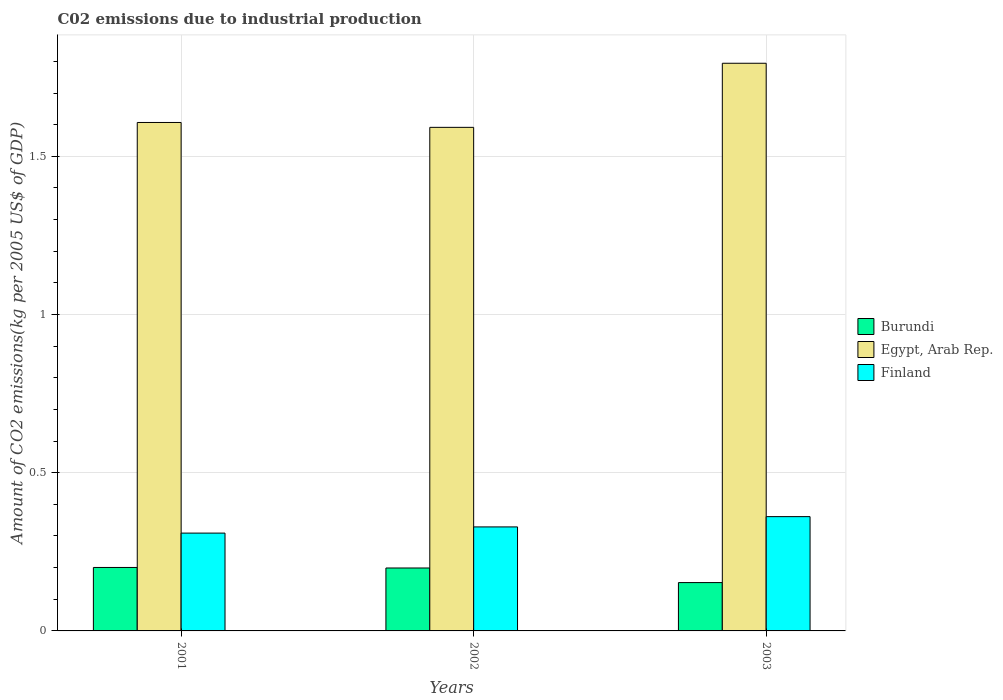How many different coloured bars are there?
Provide a succinct answer. 3. How many bars are there on the 3rd tick from the left?
Your answer should be compact. 3. What is the amount of CO2 emitted due to industrial production in Finland in 2003?
Your answer should be very brief. 0.36. Across all years, what is the maximum amount of CO2 emitted due to industrial production in Finland?
Provide a succinct answer. 0.36. Across all years, what is the minimum amount of CO2 emitted due to industrial production in Egypt, Arab Rep.?
Offer a terse response. 1.59. In which year was the amount of CO2 emitted due to industrial production in Egypt, Arab Rep. minimum?
Keep it short and to the point. 2002. What is the total amount of CO2 emitted due to industrial production in Finland in the graph?
Offer a terse response. 1. What is the difference between the amount of CO2 emitted due to industrial production in Egypt, Arab Rep. in 2001 and that in 2002?
Provide a short and direct response. 0.02. What is the difference between the amount of CO2 emitted due to industrial production in Finland in 2003 and the amount of CO2 emitted due to industrial production in Burundi in 2001?
Keep it short and to the point. 0.16. What is the average amount of CO2 emitted due to industrial production in Burundi per year?
Your answer should be compact. 0.18. In the year 2003, what is the difference between the amount of CO2 emitted due to industrial production in Finland and amount of CO2 emitted due to industrial production in Egypt, Arab Rep.?
Offer a terse response. -1.43. In how many years, is the amount of CO2 emitted due to industrial production in Burundi greater than 0.30000000000000004 kg?
Your response must be concise. 0. What is the ratio of the amount of CO2 emitted due to industrial production in Finland in 2001 to that in 2003?
Ensure brevity in your answer.  0.86. Is the difference between the amount of CO2 emitted due to industrial production in Finland in 2001 and 2002 greater than the difference between the amount of CO2 emitted due to industrial production in Egypt, Arab Rep. in 2001 and 2002?
Keep it short and to the point. No. What is the difference between the highest and the second highest amount of CO2 emitted due to industrial production in Burundi?
Offer a very short reply. 0. What is the difference between the highest and the lowest amount of CO2 emitted due to industrial production in Burundi?
Ensure brevity in your answer.  0.05. In how many years, is the amount of CO2 emitted due to industrial production in Egypt, Arab Rep. greater than the average amount of CO2 emitted due to industrial production in Egypt, Arab Rep. taken over all years?
Make the answer very short. 1. What does the 1st bar from the left in 2003 represents?
Your answer should be compact. Burundi. What does the 1st bar from the right in 2003 represents?
Your answer should be compact. Finland. Is it the case that in every year, the sum of the amount of CO2 emitted due to industrial production in Burundi and amount of CO2 emitted due to industrial production in Finland is greater than the amount of CO2 emitted due to industrial production in Egypt, Arab Rep.?
Give a very brief answer. No. What is the title of the graph?
Your answer should be very brief. C02 emissions due to industrial production. What is the label or title of the X-axis?
Provide a succinct answer. Years. What is the label or title of the Y-axis?
Provide a short and direct response. Amount of CO2 emissions(kg per 2005 US$ of GDP). What is the Amount of CO2 emissions(kg per 2005 US$ of GDP) of Burundi in 2001?
Your answer should be very brief. 0.2. What is the Amount of CO2 emissions(kg per 2005 US$ of GDP) of Egypt, Arab Rep. in 2001?
Offer a terse response. 1.61. What is the Amount of CO2 emissions(kg per 2005 US$ of GDP) in Finland in 2001?
Your answer should be compact. 0.31. What is the Amount of CO2 emissions(kg per 2005 US$ of GDP) in Burundi in 2002?
Your answer should be compact. 0.2. What is the Amount of CO2 emissions(kg per 2005 US$ of GDP) in Egypt, Arab Rep. in 2002?
Your response must be concise. 1.59. What is the Amount of CO2 emissions(kg per 2005 US$ of GDP) in Finland in 2002?
Your answer should be compact. 0.33. What is the Amount of CO2 emissions(kg per 2005 US$ of GDP) in Burundi in 2003?
Your answer should be very brief. 0.15. What is the Amount of CO2 emissions(kg per 2005 US$ of GDP) of Egypt, Arab Rep. in 2003?
Offer a terse response. 1.79. What is the Amount of CO2 emissions(kg per 2005 US$ of GDP) in Finland in 2003?
Your response must be concise. 0.36. Across all years, what is the maximum Amount of CO2 emissions(kg per 2005 US$ of GDP) of Burundi?
Ensure brevity in your answer.  0.2. Across all years, what is the maximum Amount of CO2 emissions(kg per 2005 US$ of GDP) in Egypt, Arab Rep.?
Provide a short and direct response. 1.79. Across all years, what is the maximum Amount of CO2 emissions(kg per 2005 US$ of GDP) in Finland?
Provide a succinct answer. 0.36. Across all years, what is the minimum Amount of CO2 emissions(kg per 2005 US$ of GDP) of Burundi?
Your answer should be compact. 0.15. Across all years, what is the minimum Amount of CO2 emissions(kg per 2005 US$ of GDP) in Egypt, Arab Rep.?
Your response must be concise. 1.59. Across all years, what is the minimum Amount of CO2 emissions(kg per 2005 US$ of GDP) in Finland?
Your response must be concise. 0.31. What is the total Amount of CO2 emissions(kg per 2005 US$ of GDP) of Burundi in the graph?
Ensure brevity in your answer.  0.55. What is the total Amount of CO2 emissions(kg per 2005 US$ of GDP) in Egypt, Arab Rep. in the graph?
Provide a succinct answer. 4.99. What is the difference between the Amount of CO2 emissions(kg per 2005 US$ of GDP) of Burundi in 2001 and that in 2002?
Keep it short and to the point. 0. What is the difference between the Amount of CO2 emissions(kg per 2005 US$ of GDP) of Egypt, Arab Rep. in 2001 and that in 2002?
Ensure brevity in your answer.  0.02. What is the difference between the Amount of CO2 emissions(kg per 2005 US$ of GDP) of Finland in 2001 and that in 2002?
Make the answer very short. -0.02. What is the difference between the Amount of CO2 emissions(kg per 2005 US$ of GDP) in Burundi in 2001 and that in 2003?
Your answer should be very brief. 0.05. What is the difference between the Amount of CO2 emissions(kg per 2005 US$ of GDP) of Egypt, Arab Rep. in 2001 and that in 2003?
Provide a short and direct response. -0.19. What is the difference between the Amount of CO2 emissions(kg per 2005 US$ of GDP) in Finland in 2001 and that in 2003?
Give a very brief answer. -0.05. What is the difference between the Amount of CO2 emissions(kg per 2005 US$ of GDP) of Burundi in 2002 and that in 2003?
Keep it short and to the point. 0.05. What is the difference between the Amount of CO2 emissions(kg per 2005 US$ of GDP) of Egypt, Arab Rep. in 2002 and that in 2003?
Your answer should be compact. -0.2. What is the difference between the Amount of CO2 emissions(kg per 2005 US$ of GDP) of Finland in 2002 and that in 2003?
Offer a very short reply. -0.03. What is the difference between the Amount of CO2 emissions(kg per 2005 US$ of GDP) in Burundi in 2001 and the Amount of CO2 emissions(kg per 2005 US$ of GDP) in Egypt, Arab Rep. in 2002?
Make the answer very short. -1.39. What is the difference between the Amount of CO2 emissions(kg per 2005 US$ of GDP) of Burundi in 2001 and the Amount of CO2 emissions(kg per 2005 US$ of GDP) of Finland in 2002?
Offer a terse response. -0.13. What is the difference between the Amount of CO2 emissions(kg per 2005 US$ of GDP) in Egypt, Arab Rep. in 2001 and the Amount of CO2 emissions(kg per 2005 US$ of GDP) in Finland in 2002?
Make the answer very short. 1.28. What is the difference between the Amount of CO2 emissions(kg per 2005 US$ of GDP) of Burundi in 2001 and the Amount of CO2 emissions(kg per 2005 US$ of GDP) of Egypt, Arab Rep. in 2003?
Keep it short and to the point. -1.59. What is the difference between the Amount of CO2 emissions(kg per 2005 US$ of GDP) of Burundi in 2001 and the Amount of CO2 emissions(kg per 2005 US$ of GDP) of Finland in 2003?
Keep it short and to the point. -0.16. What is the difference between the Amount of CO2 emissions(kg per 2005 US$ of GDP) of Egypt, Arab Rep. in 2001 and the Amount of CO2 emissions(kg per 2005 US$ of GDP) of Finland in 2003?
Ensure brevity in your answer.  1.25. What is the difference between the Amount of CO2 emissions(kg per 2005 US$ of GDP) of Burundi in 2002 and the Amount of CO2 emissions(kg per 2005 US$ of GDP) of Egypt, Arab Rep. in 2003?
Ensure brevity in your answer.  -1.6. What is the difference between the Amount of CO2 emissions(kg per 2005 US$ of GDP) of Burundi in 2002 and the Amount of CO2 emissions(kg per 2005 US$ of GDP) of Finland in 2003?
Provide a short and direct response. -0.16. What is the difference between the Amount of CO2 emissions(kg per 2005 US$ of GDP) of Egypt, Arab Rep. in 2002 and the Amount of CO2 emissions(kg per 2005 US$ of GDP) of Finland in 2003?
Offer a terse response. 1.23. What is the average Amount of CO2 emissions(kg per 2005 US$ of GDP) in Burundi per year?
Your answer should be compact. 0.18. What is the average Amount of CO2 emissions(kg per 2005 US$ of GDP) of Egypt, Arab Rep. per year?
Ensure brevity in your answer.  1.66. What is the average Amount of CO2 emissions(kg per 2005 US$ of GDP) of Finland per year?
Keep it short and to the point. 0.33. In the year 2001, what is the difference between the Amount of CO2 emissions(kg per 2005 US$ of GDP) in Burundi and Amount of CO2 emissions(kg per 2005 US$ of GDP) in Egypt, Arab Rep.?
Offer a terse response. -1.41. In the year 2001, what is the difference between the Amount of CO2 emissions(kg per 2005 US$ of GDP) in Burundi and Amount of CO2 emissions(kg per 2005 US$ of GDP) in Finland?
Your response must be concise. -0.11. In the year 2001, what is the difference between the Amount of CO2 emissions(kg per 2005 US$ of GDP) in Egypt, Arab Rep. and Amount of CO2 emissions(kg per 2005 US$ of GDP) in Finland?
Give a very brief answer. 1.3. In the year 2002, what is the difference between the Amount of CO2 emissions(kg per 2005 US$ of GDP) in Burundi and Amount of CO2 emissions(kg per 2005 US$ of GDP) in Egypt, Arab Rep.?
Your answer should be compact. -1.39. In the year 2002, what is the difference between the Amount of CO2 emissions(kg per 2005 US$ of GDP) of Burundi and Amount of CO2 emissions(kg per 2005 US$ of GDP) of Finland?
Ensure brevity in your answer.  -0.13. In the year 2002, what is the difference between the Amount of CO2 emissions(kg per 2005 US$ of GDP) of Egypt, Arab Rep. and Amount of CO2 emissions(kg per 2005 US$ of GDP) of Finland?
Provide a short and direct response. 1.26. In the year 2003, what is the difference between the Amount of CO2 emissions(kg per 2005 US$ of GDP) of Burundi and Amount of CO2 emissions(kg per 2005 US$ of GDP) of Egypt, Arab Rep.?
Your answer should be very brief. -1.64. In the year 2003, what is the difference between the Amount of CO2 emissions(kg per 2005 US$ of GDP) of Burundi and Amount of CO2 emissions(kg per 2005 US$ of GDP) of Finland?
Offer a very short reply. -0.21. In the year 2003, what is the difference between the Amount of CO2 emissions(kg per 2005 US$ of GDP) of Egypt, Arab Rep. and Amount of CO2 emissions(kg per 2005 US$ of GDP) of Finland?
Your response must be concise. 1.43. What is the ratio of the Amount of CO2 emissions(kg per 2005 US$ of GDP) of Burundi in 2001 to that in 2002?
Your answer should be compact. 1.01. What is the ratio of the Amount of CO2 emissions(kg per 2005 US$ of GDP) of Egypt, Arab Rep. in 2001 to that in 2002?
Your answer should be compact. 1.01. What is the ratio of the Amount of CO2 emissions(kg per 2005 US$ of GDP) of Finland in 2001 to that in 2002?
Give a very brief answer. 0.94. What is the ratio of the Amount of CO2 emissions(kg per 2005 US$ of GDP) of Burundi in 2001 to that in 2003?
Ensure brevity in your answer.  1.31. What is the ratio of the Amount of CO2 emissions(kg per 2005 US$ of GDP) in Egypt, Arab Rep. in 2001 to that in 2003?
Offer a very short reply. 0.9. What is the ratio of the Amount of CO2 emissions(kg per 2005 US$ of GDP) in Finland in 2001 to that in 2003?
Provide a short and direct response. 0.86. What is the ratio of the Amount of CO2 emissions(kg per 2005 US$ of GDP) in Burundi in 2002 to that in 2003?
Keep it short and to the point. 1.3. What is the ratio of the Amount of CO2 emissions(kg per 2005 US$ of GDP) of Egypt, Arab Rep. in 2002 to that in 2003?
Your answer should be very brief. 0.89. What is the ratio of the Amount of CO2 emissions(kg per 2005 US$ of GDP) in Finland in 2002 to that in 2003?
Offer a terse response. 0.91. What is the difference between the highest and the second highest Amount of CO2 emissions(kg per 2005 US$ of GDP) of Burundi?
Ensure brevity in your answer.  0. What is the difference between the highest and the second highest Amount of CO2 emissions(kg per 2005 US$ of GDP) in Egypt, Arab Rep.?
Keep it short and to the point. 0.19. What is the difference between the highest and the second highest Amount of CO2 emissions(kg per 2005 US$ of GDP) of Finland?
Keep it short and to the point. 0.03. What is the difference between the highest and the lowest Amount of CO2 emissions(kg per 2005 US$ of GDP) in Burundi?
Make the answer very short. 0.05. What is the difference between the highest and the lowest Amount of CO2 emissions(kg per 2005 US$ of GDP) of Egypt, Arab Rep.?
Provide a short and direct response. 0.2. What is the difference between the highest and the lowest Amount of CO2 emissions(kg per 2005 US$ of GDP) in Finland?
Offer a terse response. 0.05. 